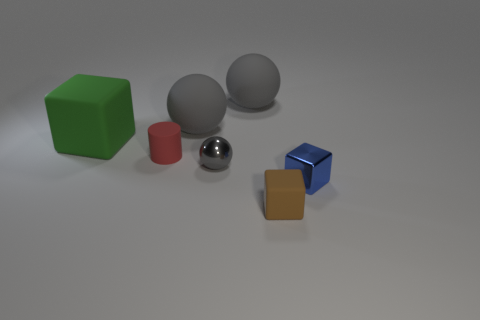Is the material of the gray thing in front of the green cube the same as the tiny blue thing?
Offer a very short reply. Yes. There is a gray thing that is in front of the green thing; what shape is it?
Your answer should be very brief. Sphere. What number of gray things have the same size as the blue thing?
Ensure brevity in your answer.  1. What size is the brown block?
Make the answer very short. Small. There is a small gray metallic object; what number of tiny metal blocks are to the right of it?
Offer a very short reply. 1. What shape is the tiny thing that is made of the same material as the red cylinder?
Provide a succinct answer. Cube. Are there fewer red cylinders in front of the tiny blue metal block than large green rubber cubes that are in front of the tiny brown matte block?
Keep it short and to the point. No. Is the number of tiny brown objects greater than the number of blue shiny spheres?
Offer a terse response. Yes. What is the material of the blue block?
Your answer should be very brief. Metal. What is the color of the tiny matte thing behind the tiny metal block?
Keep it short and to the point. Red. 